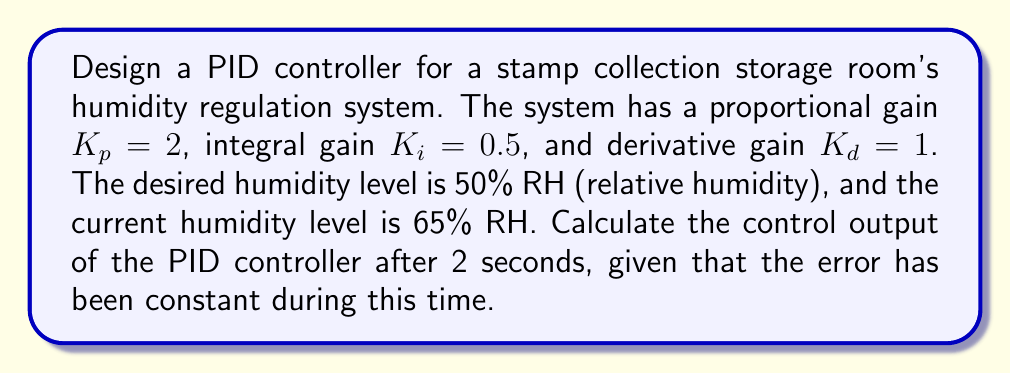What is the answer to this math problem? To solve this problem, we'll follow these steps:

1) First, let's recall the PID controller equation:

   $$u(t) = K_p e(t) + K_i \int_0^t e(\tau) d\tau + K_d \frac{de(t)}{dt}$$

   Where:
   - $u(t)$ is the control output
   - $e(t)$ is the error (difference between desired and actual value)
   - $K_p$, $K_i$, and $K_d$ are the proportional, integral, and derivative gains respectively

2) Calculate the error:
   
   $e(t) = \text{Desired Value} - \text{Actual Value} = 50\% - 65\% = -15\%$

3) Since the error is constant, the derivative term will be zero:

   $$K_d \frac{de(t)}{dt} = 1 \cdot 0 = 0$$

4) For the integral term, we integrate the constant error over 2 seconds:

   $$K_i \int_0^t e(\tau) d\tau = 0.5 \cdot (-15) \cdot 2 = -15$$

5) The proportional term is simply:

   $$K_p e(t) = 2 \cdot (-15) = -30$$

6) Sum all terms to get the control output:

   $$u(t) = -30 + (-15) + 0 = -45$$

The negative output indicates that the controller needs to decrease the humidity level.
Answer: The control output of the PID controller after 2 seconds is $-45$. 